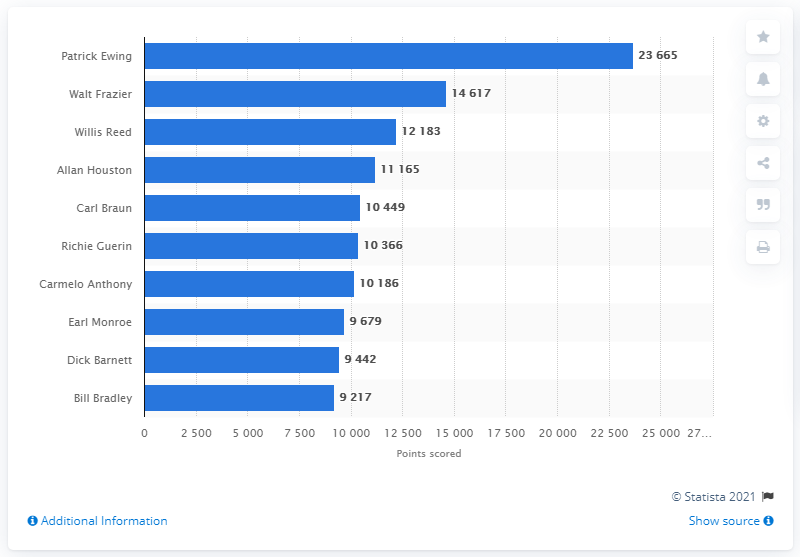Give some essential details in this illustration. Patrick Ewing is the career points leader of the New York Knicks. 